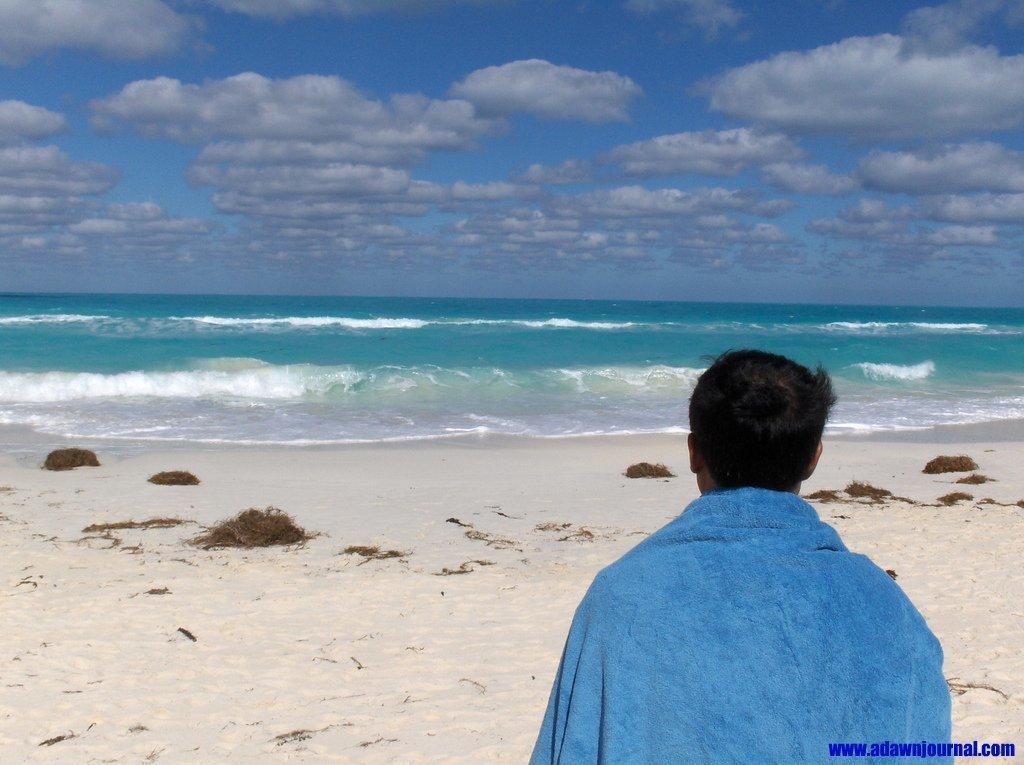Could you give a brief overview of what you see in this image? This image is taken at the beach. In this image we can see a man. We can also see the water, sand and also the sky with the clouds. In the bottom right corner we can see the text. 